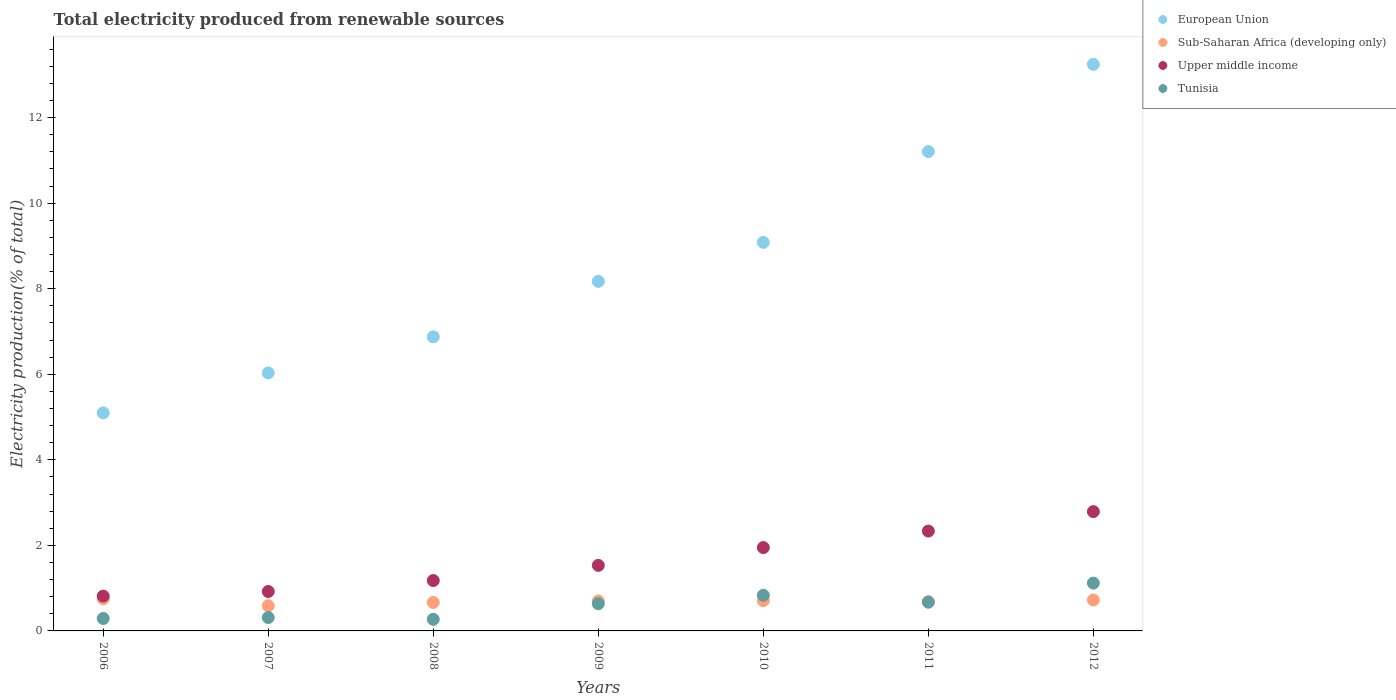How many different coloured dotlines are there?
Provide a succinct answer. 4. Is the number of dotlines equal to the number of legend labels?
Offer a very short reply. Yes. What is the total electricity produced in Tunisia in 2011?
Provide a short and direct response. 0.67. Across all years, what is the maximum total electricity produced in Tunisia?
Offer a terse response. 1.12. Across all years, what is the minimum total electricity produced in Sub-Saharan Africa (developing only)?
Offer a very short reply. 0.59. In which year was the total electricity produced in Upper middle income maximum?
Offer a terse response. 2012. What is the total total electricity produced in Upper middle income in the graph?
Ensure brevity in your answer.  11.52. What is the difference between the total electricity produced in Sub-Saharan Africa (developing only) in 2007 and that in 2008?
Offer a terse response. -0.08. What is the difference between the total electricity produced in Tunisia in 2008 and the total electricity produced in Upper middle income in 2010?
Provide a succinct answer. -1.68. What is the average total electricity produced in Sub-Saharan Africa (developing only) per year?
Offer a very short reply. 0.69. In the year 2008, what is the difference between the total electricity produced in Tunisia and total electricity produced in Sub-Saharan Africa (developing only)?
Provide a short and direct response. -0.39. What is the ratio of the total electricity produced in European Union in 2008 to that in 2010?
Ensure brevity in your answer.  0.76. Is the total electricity produced in Sub-Saharan Africa (developing only) in 2006 less than that in 2010?
Give a very brief answer. No. Is the difference between the total electricity produced in Tunisia in 2008 and 2009 greater than the difference between the total electricity produced in Sub-Saharan Africa (developing only) in 2008 and 2009?
Your answer should be compact. No. What is the difference between the highest and the second highest total electricity produced in Upper middle income?
Keep it short and to the point. 0.45. What is the difference between the highest and the lowest total electricity produced in Tunisia?
Offer a very short reply. 0.85. Is it the case that in every year, the sum of the total electricity produced in European Union and total electricity produced in Tunisia  is greater than the total electricity produced in Upper middle income?
Your answer should be very brief. Yes. Is the total electricity produced in Tunisia strictly less than the total electricity produced in Upper middle income over the years?
Keep it short and to the point. Yes. How many years are there in the graph?
Your answer should be compact. 7. What is the difference between two consecutive major ticks on the Y-axis?
Offer a terse response. 2. Does the graph contain any zero values?
Offer a terse response. No. Does the graph contain grids?
Give a very brief answer. No. What is the title of the graph?
Keep it short and to the point. Total electricity produced from renewable sources. Does "East Asia (all income levels)" appear as one of the legend labels in the graph?
Give a very brief answer. No. What is the Electricity production(% of total) in European Union in 2006?
Provide a short and direct response. 5.1. What is the Electricity production(% of total) in Sub-Saharan Africa (developing only) in 2006?
Provide a short and direct response. 0.75. What is the Electricity production(% of total) of Upper middle income in 2006?
Provide a short and direct response. 0.81. What is the Electricity production(% of total) of Tunisia in 2006?
Your response must be concise. 0.29. What is the Electricity production(% of total) in European Union in 2007?
Offer a terse response. 6.03. What is the Electricity production(% of total) in Sub-Saharan Africa (developing only) in 2007?
Give a very brief answer. 0.59. What is the Electricity production(% of total) in Upper middle income in 2007?
Give a very brief answer. 0.92. What is the Electricity production(% of total) of Tunisia in 2007?
Give a very brief answer. 0.31. What is the Electricity production(% of total) in European Union in 2008?
Make the answer very short. 6.87. What is the Electricity production(% of total) of Sub-Saharan Africa (developing only) in 2008?
Your answer should be compact. 0.67. What is the Electricity production(% of total) in Upper middle income in 2008?
Give a very brief answer. 1.18. What is the Electricity production(% of total) of Tunisia in 2008?
Ensure brevity in your answer.  0.27. What is the Electricity production(% of total) in European Union in 2009?
Your answer should be compact. 8.17. What is the Electricity production(% of total) of Sub-Saharan Africa (developing only) in 2009?
Your answer should be compact. 0.7. What is the Electricity production(% of total) in Upper middle income in 2009?
Your answer should be very brief. 1.53. What is the Electricity production(% of total) in Tunisia in 2009?
Your response must be concise. 0.64. What is the Electricity production(% of total) of European Union in 2010?
Your answer should be compact. 9.08. What is the Electricity production(% of total) of Sub-Saharan Africa (developing only) in 2010?
Your response must be concise. 0.71. What is the Electricity production(% of total) of Upper middle income in 2010?
Keep it short and to the point. 1.95. What is the Electricity production(% of total) in Tunisia in 2010?
Ensure brevity in your answer.  0.83. What is the Electricity production(% of total) of European Union in 2011?
Provide a succinct answer. 11.21. What is the Electricity production(% of total) in Sub-Saharan Africa (developing only) in 2011?
Provide a succinct answer. 0.69. What is the Electricity production(% of total) of Upper middle income in 2011?
Offer a very short reply. 2.33. What is the Electricity production(% of total) in Tunisia in 2011?
Offer a terse response. 0.67. What is the Electricity production(% of total) of European Union in 2012?
Your answer should be compact. 13.25. What is the Electricity production(% of total) of Sub-Saharan Africa (developing only) in 2012?
Keep it short and to the point. 0.72. What is the Electricity production(% of total) of Upper middle income in 2012?
Make the answer very short. 2.79. What is the Electricity production(% of total) of Tunisia in 2012?
Make the answer very short. 1.12. Across all years, what is the maximum Electricity production(% of total) of European Union?
Make the answer very short. 13.25. Across all years, what is the maximum Electricity production(% of total) of Sub-Saharan Africa (developing only)?
Your answer should be compact. 0.75. Across all years, what is the maximum Electricity production(% of total) in Upper middle income?
Keep it short and to the point. 2.79. Across all years, what is the maximum Electricity production(% of total) of Tunisia?
Your answer should be very brief. 1.12. Across all years, what is the minimum Electricity production(% of total) of European Union?
Offer a terse response. 5.1. Across all years, what is the minimum Electricity production(% of total) of Sub-Saharan Africa (developing only)?
Provide a short and direct response. 0.59. Across all years, what is the minimum Electricity production(% of total) in Upper middle income?
Offer a very short reply. 0.81. Across all years, what is the minimum Electricity production(% of total) of Tunisia?
Provide a succinct answer. 0.27. What is the total Electricity production(% of total) of European Union in the graph?
Offer a terse response. 59.71. What is the total Electricity production(% of total) in Sub-Saharan Africa (developing only) in the graph?
Offer a very short reply. 4.82. What is the total Electricity production(% of total) of Upper middle income in the graph?
Give a very brief answer. 11.52. What is the total Electricity production(% of total) in Tunisia in the graph?
Offer a terse response. 4.13. What is the difference between the Electricity production(% of total) in European Union in 2006 and that in 2007?
Make the answer very short. -0.94. What is the difference between the Electricity production(% of total) in Sub-Saharan Africa (developing only) in 2006 and that in 2007?
Make the answer very short. 0.16. What is the difference between the Electricity production(% of total) in Upper middle income in 2006 and that in 2007?
Offer a very short reply. -0.11. What is the difference between the Electricity production(% of total) in Tunisia in 2006 and that in 2007?
Your answer should be very brief. -0.02. What is the difference between the Electricity production(% of total) in European Union in 2006 and that in 2008?
Ensure brevity in your answer.  -1.78. What is the difference between the Electricity production(% of total) of Sub-Saharan Africa (developing only) in 2006 and that in 2008?
Your response must be concise. 0.09. What is the difference between the Electricity production(% of total) of Upper middle income in 2006 and that in 2008?
Make the answer very short. -0.36. What is the difference between the Electricity production(% of total) of Tunisia in 2006 and that in 2008?
Provide a short and direct response. 0.02. What is the difference between the Electricity production(% of total) of European Union in 2006 and that in 2009?
Give a very brief answer. -3.07. What is the difference between the Electricity production(% of total) of Sub-Saharan Africa (developing only) in 2006 and that in 2009?
Provide a short and direct response. 0.05. What is the difference between the Electricity production(% of total) of Upper middle income in 2006 and that in 2009?
Offer a very short reply. -0.72. What is the difference between the Electricity production(% of total) of Tunisia in 2006 and that in 2009?
Give a very brief answer. -0.34. What is the difference between the Electricity production(% of total) in European Union in 2006 and that in 2010?
Offer a very short reply. -3.99. What is the difference between the Electricity production(% of total) in Sub-Saharan Africa (developing only) in 2006 and that in 2010?
Make the answer very short. 0.04. What is the difference between the Electricity production(% of total) in Upper middle income in 2006 and that in 2010?
Your answer should be very brief. -1.13. What is the difference between the Electricity production(% of total) in Tunisia in 2006 and that in 2010?
Your response must be concise. -0.54. What is the difference between the Electricity production(% of total) in European Union in 2006 and that in 2011?
Keep it short and to the point. -6.11. What is the difference between the Electricity production(% of total) of Sub-Saharan Africa (developing only) in 2006 and that in 2011?
Provide a succinct answer. 0.07. What is the difference between the Electricity production(% of total) in Upper middle income in 2006 and that in 2011?
Offer a very short reply. -1.52. What is the difference between the Electricity production(% of total) of Tunisia in 2006 and that in 2011?
Keep it short and to the point. -0.38. What is the difference between the Electricity production(% of total) in European Union in 2006 and that in 2012?
Give a very brief answer. -8.15. What is the difference between the Electricity production(% of total) in Sub-Saharan Africa (developing only) in 2006 and that in 2012?
Keep it short and to the point. 0.03. What is the difference between the Electricity production(% of total) in Upper middle income in 2006 and that in 2012?
Your response must be concise. -1.97. What is the difference between the Electricity production(% of total) in Tunisia in 2006 and that in 2012?
Offer a very short reply. -0.83. What is the difference between the Electricity production(% of total) in European Union in 2007 and that in 2008?
Keep it short and to the point. -0.84. What is the difference between the Electricity production(% of total) of Sub-Saharan Africa (developing only) in 2007 and that in 2008?
Your answer should be compact. -0.08. What is the difference between the Electricity production(% of total) of Upper middle income in 2007 and that in 2008?
Offer a very short reply. -0.26. What is the difference between the Electricity production(% of total) of Tunisia in 2007 and that in 2008?
Your response must be concise. 0.04. What is the difference between the Electricity production(% of total) in European Union in 2007 and that in 2009?
Give a very brief answer. -2.14. What is the difference between the Electricity production(% of total) of Sub-Saharan Africa (developing only) in 2007 and that in 2009?
Ensure brevity in your answer.  -0.11. What is the difference between the Electricity production(% of total) of Upper middle income in 2007 and that in 2009?
Provide a short and direct response. -0.61. What is the difference between the Electricity production(% of total) in Tunisia in 2007 and that in 2009?
Your response must be concise. -0.32. What is the difference between the Electricity production(% of total) of European Union in 2007 and that in 2010?
Provide a short and direct response. -3.05. What is the difference between the Electricity production(% of total) in Sub-Saharan Africa (developing only) in 2007 and that in 2010?
Your answer should be very brief. -0.12. What is the difference between the Electricity production(% of total) of Upper middle income in 2007 and that in 2010?
Ensure brevity in your answer.  -1.03. What is the difference between the Electricity production(% of total) of Tunisia in 2007 and that in 2010?
Your answer should be compact. -0.52. What is the difference between the Electricity production(% of total) in European Union in 2007 and that in 2011?
Your response must be concise. -5.17. What is the difference between the Electricity production(% of total) of Sub-Saharan Africa (developing only) in 2007 and that in 2011?
Provide a short and direct response. -0.1. What is the difference between the Electricity production(% of total) of Upper middle income in 2007 and that in 2011?
Your answer should be very brief. -1.41. What is the difference between the Electricity production(% of total) of Tunisia in 2007 and that in 2011?
Offer a very short reply. -0.36. What is the difference between the Electricity production(% of total) of European Union in 2007 and that in 2012?
Your response must be concise. -7.21. What is the difference between the Electricity production(% of total) of Sub-Saharan Africa (developing only) in 2007 and that in 2012?
Make the answer very short. -0.13. What is the difference between the Electricity production(% of total) in Upper middle income in 2007 and that in 2012?
Provide a short and direct response. -1.87. What is the difference between the Electricity production(% of total) in Tunisia in 2007 and that in 2012?
Offer a terse response. -0.8. What is the difference between the Electricity production(% of total) of European Union in 2008 and that in 2009?
Provide a succinct answer. -1.3. What is the difference between the Electricity production(% of total) of Sub-Saharan Africa (developing only) in 2008 and that in 2009?
Make the answer very short. -0.03. What is the difference between the Electricity production(% of total) of Upper middle income in 2008 and that in 2009?
Give a very brief answer. -0.35. What is the difference between the Electricity production(% of total) of Tunisia in 2008 and that in 2009?
Give a very brief answer. -0.36. What is the difference between the Electricity production(% of total) in European Union in 2008 and that in 2010?
Provide a succinct answer. -2.21. What is the difference between the Electricity production(% of total) of Sub-Saharan Africa (developing only) in 2008 and that in 2010?
Make the answer very short. -0.04. What is the difference between the Electricity production(% of total) of Upper middle income in 2008 and that in 2010?
Give a very brief answer. -0.77. What is the difference between the Electricity production(% of total) of Tunisia in 2008 and that in 2010?
Give a very brief answer. -0.56. What is the difference between the Electricity production(% of total) of European Union in 2008 and that in 2011?
Offer a terse response. -4.33. What is the difference between the Electricity production(% of total) of Sub-Saharan Africa (developing only) in 2008 and that in 2011?
Offer a terse response. -0.02. What is the difference between the Electricity production(% of total) in Upper middle income in 2008 and that in 2011?
Keep it short and to the point. -1.16. What is the difference between the Electricity production(% of total) in Tunisia in 2008 and that in 2011?
Offer a very short reply. -0.4. What is the difference between the Electricity production(% of total) of European Union in 2008 and that in 2012?
Make the answer very short. -6.37. What is the difference between the Electricity production(% of total) of Sub-Saharan Africa (developing only) in 2008 and that in 2012?
Provide a short and direct response. -0.06. What is the difference between the Electricity production(% of total) of Upper middle income in 2008 and that in 2012?
Your answer should be compact. -1.61. What is the difference between the Electricity production(% of total) in Tunisia in 2008 and that in 2012?
Give a very brief answer. -0.85. What is the difference between the Electricity production(% of total) in European Union in 2009 and that in 2010?
Give a very brief answer. -0.91. What is the difference between the Electricity production(% of total) of Sub-Saharan Africa (developing only) in 2009 and that in 2010?
Offer a terse response. -0.01. What is the difference between the Electricity production(% of total) of Upper middle income in 2009 and that in 2010?
Keep it short and to the point. -0.42. What is the difference between the Electricity production(% of total) of Tunisia in 2009 and that in 2010?
Your answer should be very brief. -0.2. What is the difference between the Electricity production(% of total) in European Union in 2009 and that in 2011?
Offer a very short reply. -3.04. What is the difference between the Electricity production(% of total) of Sub-Saharan Africa (developing only) in 2009 and that in 2011?
Your answer should be compact. 0.01. What is the difference between the Electricity production(% of total) of Upper middle income in 2009 and that in 2011?
Provide a short and direct response. -0.8. What is the difference between the Electricity production(% of total) of Tunisia in 2009 and that in 2011?
Make the answer very short. -0.04. What is the difference between the Electricity production(% of total) in European Union in 2009 and that in 2012?
Offer a very short reply. -5.07. What is the difference between the Electricity production(% of total) of Sub-Saharan Africa (developing only) in 2009 and that in 2012?
Offer a very short reply. -0.02. What is the difference between the Electricity production(% of total) in Upper middle income in 2009 and that in 2012?
Your answer should be very brief. -1.26. What is the difference between the Electricity production(% of total) in Tunisia in 2009 and that in 2012?
Your response must be concise. -0.48. What is the difference between the Electricity production(% of total) in European Union in 2010 and that in 2011?
Your answer should be very brief. -2.12. What is the difference between the Electricity production(% of total) in Sub-Saharan Africa (developing only) in 2010 and that in 2011?
Make the answer very short. 0.02. What is the difference between the Electricity production(% of total) in Upper middle income in 2010 and that in 2011?
Make the answer very short. -0.39. What is the difference between the Electricity production(% of total) of Tunisia in 2010 and that in 2011?
Offer a terse response. 0.16. What is the difference between the Electricity production(% of total) of European Union in 2010 and that in 2012?
Make the answer very short. -4.16. What is the difference between the Electricity production(% of total) in Sub-Saharan Africa (developing only) in 2010 and that in 2012?
Offer a very short reply. -0.02. What is the difference between the Electricity production(% of total) in Upper middle income in 2010 and that in 2012?
Your answer should be compact. -0.84. What is the difference between the Electricity production(% of total) of Tunisia in 2010 and that in 2012?
Make the answer very short. -0.28. What is the difference between the Electricity production(% of total) of European Union in 2011 and that in 2012?
Provide a succinct answer. -2.04. What is the difference between the Electricity production(% of total) of Sub-Saharan Africa (developing only) in 2011 and that in 2012?
Provide a short and direct response. -0.04. What is the difference between the Electricity production(% of total) of Upper middle income in 2011 and that in 2012?
Keep it short and to the point. -0.45. What is the difference between the Electricity production(% of total) in Tunisia in 2011 and that in 2012?
Make the answer very short. -0.45. What is the difference between the Electricity production(% of total) of European Union in 2006 and the Electricity production(% of total) of Sub-Saharan Africa (developing only) in 2007?
Offer a very short reply. 4.51. What is the difference between the Electricity production(% of total) of European Union in 2006 and the Electricity production(% of total) of Upper middle income in 2007?
Offer a terse response. 4.17. What is the difference between the Electricity production(% of total) in European Union in 2006 and the Electricity production(% of total) in Tunisia in 2007?
Your answer should be very brief. 4.78. What is the difference between the Electricity production(% of total) in Sub-Saharan Africa (developing only) in 2006 and the Electricity production(% of total) in Upper middle income in 2007?
Ensure brevity in your answer.  -0.17. What is the difference between the Electricity production(% of total) in Sub-Saharan Africa (developing only) in 2006 and the Electricity production(% of total) in Tunisia in 2007?
Offer a very short reply. 0.44. What is the difference between the Electricity production(% of total) in Upper middle income in 2006 and the Electricity production(% of total) in Tunisia in 2007?
Offer a terse response. 0.5. What is the difference between the Electricity production(% of total) of European Union in 2006 and the Electricity production(% of total) of Sub-Saharan Africa (developing only) in 2008?
Provide a succinct answer. 4.43. What is the difference between the Electricity production(% of total) of European Union in 2006 and the Electricity production(% of total) of Upper middle income in 2008?
Your answer should be compact. 3.92. What is the difference between the Electricity production(% of total) in European Union in 2006 and the Electricity production(% of total) in Tunisia in 2008?
Ensure brevity in your answer.  4.82. What is the difference between the Electricity production(% of total) in Sub-Saharan Africa (developing only) in 2006 and the Electricity production(% of total) in Upper middle income in 2008?
Make the answer very short. -0.43. What is the difference between the Electricity production(% of total) of Sub-Saharan Africa (developing only) in 2006 and the Electricity production(% of total) of Tunisia in 2008?
Offer a very short reply. 0.48. What is the difference between the Electricity production(% of total) in Upper middle income in 2006 and the Electricity production(% of total) in Tunisia in 2008?
Your answer should be very brief. 0.54. What is the difference between the Electricity production(% of total) in European Union in 2006 and the Electricity production(% of total) in Sub-Saharan Africa (developing only) in 2009?
Your answer should be compact. 4.4. What is the difference between the Electricity production(% of total) in European Union in 2006 and the Electricity production(% of total) in Upper middle income in 2009?
Provide a short and direct response. 3.56. What is the difference between the Electricity production(% of total) of European Union in 2006 and the Electricity production(% of total) of Tunisia in 2009?
Offer a very short reply. 4.46. What is the difference between the Electricity production(% of total) in Sub-Saharan Africa (developing only) in 2006 and the Electricity production(% of total) in Upper middle income in 2009?
Give a very brief answer. -0.78. What is the difference between the Electricity production(% of total) of Sub-Saharan Africa (developing only) in 2006 and the Electricity production(% of total) of Tunisia in 2009?
Ensure brevity in your answer.  0.12. What is the difference between the Electricity production(% of total) in Upper middle income in 2006 and the Electricity production(% of total) in Tunisia in 2009?
Provide a short and direct response. 0.18. What is the difference between the Electricity production(% of total) of European Union in 2006 and the Electricity production(% of total) of Sub-Saharan Africa (developing only) in 2010?
Your answer should be very brief. 4.39. What is the difference between the Electricity production(% of total) in European Union in 2006 and the Electricity production(% of total) in Upper middle income in 2010?
Offer a very short reply. 3.15. What is the difference between the Electricity production(% of total) of European Union in 2006 and the Electricity production(% of total) of Tunisia in 2010?
Your answer should be very brief. 4.26. What is the difference between the Electricity production(% of total) in Sub-Saharan Africa (developing only) in 2006 and the Electricity production(% of total) in Upper middle income in 2010?
Ensure brevity in your answer.  -1.2. What is the difference between the Electricity production(% of total) in Sub-Saharan Africa (developing only) in 2006 and the Electricity production(% of total) in Tunisia in 2010?
Offer a terse response. -0.08. What is the difference between the Electricity production(% of total) of Upper middle income in 2006 and the Electricity production(% of total) of Tunisia in 2010?
Keep it short and to the point. -0.02. What is the difference between the Electricity production(% of total) in European Union in 2006 and the Electricity production(% of total) in Sub-Saharan Africa (developing only) in 2011?
Your answer should be very brief. 4.41. What is the difference between the Electricity production(% of total) in European Union in 2006 and the Electricity production(% of total) in Upper middle income in 2011?
Offer a terse response. 2.76. What is the difference between the Electricity production(% of total) of European Union in 2006 and the Electricity production(% of total) of Tunisia in 2011?
Your answer should be compact. 4.43. What is the difference between the Electricity production(% of total) of Sub-Saharan Africa (developing only) in 2006 and the Electricity production(% of total) of Upper middle income in 2011?
Your answer should be very brief. -1.58. What is the difference between the Electricity production(% of total) of Sub-Saharan Africa (developing only) in 2006 and the Electricity production(% of total) of Tunisia in 2011?
Keep it short and to the point. 0.08. What is the difference between the Electricity production(% of total) of Upper middle income in 2006 and the Electricity production(% of total) of Tunisia in 2011?
Provide a succinct answer. 0.14. What is the difference between the Electricity production(% of total) of European Union in 2006 and the Electricity production(% of total) of Sub-Saharan Africa (developing only) in 2012?
Provide a short and direct response. 4.37. What is the difference between the Electricity production(% of total) of European Union in 2006 and the Electricity production(% of total) of Upper middle income in 2012?
Offer a very short reply. 2.31. What is the difference between the Electricity production(% of total) of European Union in 2006 and the Electricity production(% of total) of Tunisia in 2012?
Ensure brevity in your answer.  3.98. What is the difference between the Electricity production(% of total) of Sub-Saharan Africa (developing only) in 2006 and the Electricity production(% of total) of Upper middle income in 2012?
Offer a terse response. -2.04. What is the difference between the Electricity production(% of total) of Sub-Saharan Africa (developing only) in 2006 and the Electricity production(% of total) of Tunisia in 2012?
Ensure brevity in your answer.  -0.37. What is the difference between the Electricity production(% of total) of Upper middle income in 2006 and the Electricity production(% of total) of Tunisia in 2012?
Provide a succinct answer. -0.3. What is the difference between the Electricity production(% of total) of European Union in 2007 and the Electricity production(% of total) of Sub-Saharan Africa (developing only) in 2008?
Your response must be concise. 5.37. What is the difference between the Electricity production(% of total) in European Union in 2007 and the Electricity production(% of total) in Upper middle income in 2008?
Provide a short and direct response. 4.85. What is the difference between the Electricity production(% of total) of European Union in 2007 and the Electricity production(% of total) of Tunisia in 2008?
Make the answer very short. 5.76. What is the difference between the Electricity production(% of total) in Sub-Saharan Africa (developing only) in 2007 and the Electricity production(% of total) in Upper middle income in 2008?
Your response must be concise. -0.59. What is the difference between the Electricity production(% of total) in Sub-Saharan Africa (developing only) in 2007 and the Electricity production(% of total) in Tunisia in 2008?
Provide a succinct answer. 0.32. What is the difference between the Electricity production(% of total) of Upper middle income in 2007 and the Electricity production(% of total) of Tunisia in 2008?
Your answer should be compact. 0.65. What is the difference between the Electricity production(% of total) of European Union in 2007 and the Electricity production(% of total) of Sub-Saharan Africa (developing only) in 2009?
Make the answer very short. 5.33. What is the difference between the Electricity production(% of total) of European Union in 2007 and the Electricity production(% of total) of Upper middle income in 2009?
Keep it short and to the point. 4.5. What is the difference between the Electricity production(% of total) in European Union in 2007 and the Electricity production(% of total) in Tunisia in 2009?
Your response must be concise. 5.4. What is the difference between the Electricity production(% of total) of Sub-Saharan Africa (developing only) in 2007 and the Electricity production(% of total) of Upper middle income in 2009?
Your answer should be very brief. -0.94. What is the difference between the Electricity production(% of total) of Sub-Saharan Africa (developing only) in 2007 and the Electricity production(% of total) of Tunisia in 2009?
Offer a terse response. -0.05. What is the difference between the Electricity production(% of total) in Upper middle income in 2007 and the Electricity production(% of total) in Tunisia in 2009?
Offer a terse response. 0.29. What is the difference between the Electricity production(% of total) of European Union in 2007 and the Electricity production(% of total) of Sub-Saharan Africa (developing only) in 2010?
Give a very brief answer. 5.32. What is the difference between the Electricity production(% of total) in European Union in 2007 and the Electricity production(% of total) in Upper middle income in 2010?
Provide a succinct answer. 4.08. What is the difference between the Electricity production(% of total) in European Union in 2007 and the Electricity production(% of total) in Tunisia in 2010?
Provide a succinct answer. 5.2. What is the difference between the Electricity production(% of total) of Sub-Saharan Africa (developing only) in 2007 and the Electricity production(% of total) of Upper middle income in 2010?
Your response must be concise. -1.36. What is the difference between the Electricity production(% of total) in Sub-Saharan Africa (developing only) in 2007 and the Electricity production(% of total) in Tunisia in 2010?
Provide a succinct answer. -0.24. What is the difference between the Electricity production(% of total) of Upper middle income in 2007 and the Electricity production(% of total) of Tunisia in 2010?
Provide a succinct answer. 0.09. What is the difference between the Electricity production(% of total) of European Union in 2007 and the Electricity production(% of total) of Sub-Saharan Africa (developing only) in 2011?
Give a very brief answer. 5.35. What is the difference between the Electricity production(% of total) of European Union in 2007 and the Electricity production(% of total) of Upper middle income in 2011?
Provide a succinct answer. 3.7. What is the difference between the Electricity production(% of total) of European Union in 2007 and the Electricity production(% of total) of Tunisia in 2011?
Keep it short and to the point. 5.36. What is the difference between the Electricity production(% of total) of Sub-Saharan Africa (developing only) in 2007 and the Electricity production(% of total) of Upper middle income in 2011?
Your answer should be very brief. -1.75. What is the difference between the Electricity production(% of total) of Sub-Saharan Africa (developing only) in 2007 and the Electricity production(% of total) of Tunisia in 2011?
Your answer should be very brief. -0.08. What is the difference between the Electricity production(% of total) of Upper middle income in 2007 and the Electricity production(% of total) of Tunisia in 2011?
Provide a succinct answer. 0.25. What is the difference between the Electricity production(% of total) in European Union in 2007 and the Electricity production(% of total) in Sub-Saharan Africa (developing only) in 2012?
Offer a very short reply. 5.31. What is the difference between the Electricity production(% of total) in European Union in 2007 and the Electricity production(% of total) in Upper middle income in 2012?
Provide a short and direct response. 3.24. What is the difference between the Electricity production(% of total) of European Union in 2007 and the Electricity production(% of total) of Tunisia in 2012?
Provide a succinct answer. 4.91. What is the difference between the Electricity production(% of total) in Sub-Saharan Africa (developing only) in 2007 and the Electricity production(% of total) in Upper middle income in 2012?
Provide a short and direct response. -2.2. What is the difference between the Electricity production(% of total) in Sub-Saharan Africa (developing only) in 2007 and the Electricity production(% of total) in Tunisia in 2012?
Give a very brief answer. -0.53. What is the difference between the Electricity production(% of total) of Upper middle income in 2007 and the Electricity production(% of total) of Tunisia in 2012?
Offer a terse response. -0.2. What is the difference between the Electricity production(% of total) in European Union in 2008 and the Electricity production(% of total) in Sub-Saharan Africa (developing only) in 2009?
Provide a short and direct response. 6.18. What is the difference between the Electricity production(% of total) in European Union in 2008 and the Electricity production(% of total) in Upper middle income in 2009?
Give a very brief answer. 5.34. What is the difference between the Electricity production(% of total) in European Union in 2008 and the Electricity production(% of total) in Tunisia in 2009?
Make the answer very short. 6.24. What is the difference between the Electricity production(% of total) of Sub-Saharan Africa (developing only) in 2008 and the Electricity production(% of total) of Upper middle income in 2009?
Your response must be concise. -0.87. What is the difference between the Electricity production(% of total) of Sub-Saharan Africa (developing only) in 2008 and the Electricity production(% of total) of Tunisia in 2009?
Offer a very short reply. 0.03. What is the difference between the Electricity production(% of total) in Upper middle income in 2008 and the Electricity production(% of total) in Tunisia in 2009?
Keep it short and to the point. 0.54. What is the difference between the Electricity production(% of total) of European Union in 2008 and the Electricity production(% of total) of Sub-Saharan Africa (developing only) in 2010?
Your answer should be very brief. 6.17. What is the difference between the Electricity production(% of total) of European Union in 2008 and the Electricity production(% of total) of Upper middle income in 2010?
Provide a succinct answer. 4.93. What is the difference between the Electricity production(% of total) of European Union in 2008 and the Electricity production(% of total) of Tunisia in 2010?
Keep it short and to the point. 6.04. What is the difference between the Electricity production(% of total) of Sub-Saharan Africa (developing only) in 2008 and the Electricity production(% of total) of Upper middle income in 2010?
Your answer should be compact. -1.28. What is the difference between the Electricity production(% of total) of Sub-Saharan Africa (developing only) in 2008 and the Electricity production(% of total) of Tunisia in 2010?
Keep it short and to the point. -0.17. What is the difference between the Electricity production(% of total) in Upper middle income in 2008 and the Electricity production(% of total) in Tunisia in 2010?
Your answer should be compact. 0.35. What is the difference between the Electricity production(% of total) of European Union in 2008 and the Electricity production(% of total) of Sub-Saharan Africa (developing only) in 2011?
Make the answer very short. 6.19. What is the difference between the Electricity production(% of total) in European Union in 2008 and the Electricity production(% of total) in Upper middle income in 2011?
Give a very brief answer. 4.54. What is the difference between the Electricity production(% of total) of European Union in 2008 and the Electricity production(% of total) of Tunisia in 2011?
Your response must be concise. 6.2. What is the difference between the Electricity production(% of total) in Sub-Saharan Africa (developing only) in 2008 and the Electricity production(% of total) in Upper middle income in 2011?
Your response must be concise. -1.67. What is the difference between the Electricity production(% of total) in Sub-Saharan Africa (developing only) in 2008 and the Electricity production(% of total) in Tunisia in 2011?
Provide a succinct answer. -0.01. What is the difference between the Electricity production(% of total) of Upper middle income in 2008 and the Electricity production(% of total) of Tunisia in 2011?
Offer a very short reply. 0.51. What is the difference between the Electricity production(% of total) of European Union in 2008 and the Electricity production(% of total) of Sub-Saharan Africa (developing only) in 2012?
Provide a short and direct response. 6.15. What is the difference between the Electricity production(% of total) in European Union in 2008 and the Electricity production(% of total) in Upper middle income in 2012?
Your response must be concise. 4.09. What is the difference between the Electricity production(% of total) of European Union in 2008 and the Electricity production(% of total) of Tunisia in 2012?
Provide a short and direct response. 5.76. What is the difference between the Electricity production(% of total) of Sub-Saharan Africa (developing only) in 2008 and the Electricity production(% of total) of Upper middle income in 2012?
Your answer should be compact. -2.12. What is the difference between the Electricity production(% of total) of Sub-Saharan Africa (developing only) in 2008 and the Electricity production(% of total) of Tunisia in 2012?
Provide a succinct answer. -0.45. What is the difference between the Electricity production(% of total) of Upper middle income in 2008 and the Electricity production(% of total) of Tunisia in 2012?
Offer a terse response. 0.06. What is the difference between the Electricity production(% of total) in European Union in 2009 and the Electricity production(% of total) in Sub-Saharan Africa (developing only) in 2010?
Your answer should be very brief. 7.46. What is the difference between the Electricity production(% of total) of European Union in 2009 and the Electricity production(% of total) of Upper middle income in 2010?
Give a very brief answer. 6.22. What is the difference between the Electricity production(% of total) in European Union in 2009 and the Electricity production(% of total) in Tunisia in 2010?
Provide a succinct answer. 7.34. What is the difference between the Electricity production(% of total) of Sub-Saharan Africa (developing only) in 2009 and the Electricity production(% of total) of Upper middle income in 2010?
Your answer should be very brief. -1.25. What is the difference between the Electricity production(% of total) in Sub-Saharan Africa (developing only) in 2009 and the Electricity production(% of total) in Tunisia in 2010?
Offer a very short reply. -0.13. What is the difference between the Electricity production(% of total) of Upper middle income in 2009 and the Electricity production(% of total) of Tunisia in 2010?
Offer a very short reply. 0.7. What is the difference between the Electricity production(% of total) in European Union in 2009 and the Electricity production(% of total) in Sub-Saharan Africa (developing only) in 2011?
Ensure brevity in your answer.  7.48. What is the difference between the Electricity production(% of total) in European Union in 2009 and the Electricity production(% of total) in Upper middle income in 2011?
Keep it short and to the point. 5.84. What is the difference between the Electricity production(% of total) of European Union in 2009 and the Electricity production(% of total) of Tunisia in 2011?
Make the answer very short. 7.5. What is the difference between the Electricity production(% of total) in Sub-Saharan Africa (developing only) in 2009 and the Electricity production(% of total) in Upper middle income in 2011?
Provide a short and direct response. -1.64. What is the difference between the Electricity production(% of total) in Sub-Saharan Africa (developing only) in 2009 and the Electricity production(% of total) in Tunisia in 2011?
Offer a terse response. 0.03. What is the difference between the Electricity production(% of total) of Upper middle income in 2009 and the Electricity production(% of total) of Tunisia in 2011?
Your answer should be compact. 0.86. What is the difference between the Electricity production(% of total) in European Union in 2009 and the Electricity production(% of total) in Sub-Saharan Africa (developing only) in 2012?
Ensure brevity in your answer.  7.45. What is the difference between the Electricity production(% of total) of European Union in 2009 and the Electricity production(% of total) of Upper middle income in 2012?
Give a very brief answer. 5.38. What is the difference between the Electricity production(% of total) in European Union in 2009 and the Electricity production(% of total) in Tunisia in 2012?
Keep it short and to the point. 7.05. What is the difference between the Electricity production(% of total) in Sub-Saharan Africa (developing only) in 2009 and the Electricity production(% of total) in Upper middle income in 2012?
Offer a very short reply. -2.09. What is the difference between the Electricity production(% of total) of Sub-Saharan Africa (developing only) in 2009 and the Electricity production(% of total) of Tunisia in 2012?
Offer a terse response. -0.42. What is the difference between the Electricity production(% of total) of Upper middle income in 2009 and the Electricity production(% of total) of Tunisia in 2012?
Offer a terse response. 0.41. What is the difference between the Electricity production(% of total) in European Union in 2010 and the Electricity production(% of total) in Sub-Saharan Africa (developing only) in 2011?
Your answer should be compact. 8.4. What is the difference between the Electricity production(% of total) of European Union in 2010 and the Electricity production(% of total) of Upper middle income in 2011?
Your answer should be compact. 6.75. What is the difference between the Electricity production(% of total) in European Union in 2010 and the Electricity production(% of total) in Tunisia in 2011?
Make the answer very short. 8.41. What is the difference between the Electricity production(% of total) of Sub-Saharan Africa (developing only) in 2010 and the Electricity production(% of total) of Upper middle income in 2011?
Make the answer very short. -1.63. What is the difference between the Electricity production(% of total) in Sub-Saharan Africa (developing only) in 2010 and the Electricity production(% of total) in Tunisia in 2011?
Ensure brevity in your answer.  0.04. What is the difference between the Electricity production(% of total) in Upper middle income in 2010 and the Electricity production(% of total) in Tunisia in 2011?
Make the answer very short. 1.28. What is the difference between the Electricity production(% of total) in European Union in 2010 and the Electricity production(% of total) in Sub-Saharan Africa (developing only) in 2012?
Provide a short and direct response. 8.36. What is the difference between the Electricity production(% of total) in European Union in 2010 and the Electricity production(% of total) in Upper middle income in 2012?
Keep it short and to the point. 6.29. What is the difference between the Electricity production(% of total) in European Union in 2010 and the Electricity production(% of total) in Tunisia in 2012?
Give a very brief answer. 7.97. What is the difference between the Electricity production(% of total) of Sub-Saharan Africa (developing only) in 2010 and the Electricity production(% of total) of Upper middle income in 2012?
Offer a very short reply. -2.08. What is the difference between the Electricity production(% of total) in Sub-Saharan Africa (developing only) in 2010 and the Electricity production(% of total) in Tunisia in 2012?
Ensure brevity in your answer.  -0.41. What is the difference between the Electricity production(% of total) of Upper middle income in 2010 and the Electricity production(% of total) of Tunisia in 2012?
Make the answer very short. 0.83. What is the difference between the Electricity production(% of total) of European Union in 2011 and the Electricity production(% of total) of Sub-Saharan Africa (developing only) in 2012?
Give a very brief answer. 10.48. What is the difference between the Electricity production(% of total) in European Union in 2011 and the Electricity production(% of total) in Upper middle income in 2012?
Ensure brevity in your answer.  8.42. What is the difference between the Electricity production(% of total) of European Union in 2011 and the Electricity production(% of total) of Tunisia in 2012?
Keep it short and to the point. 10.09. What is the difference between the Electricity production(% of total) of Sub-Saharan Africa (developing only) in 2011 and the Electricity production(% of total) of Upper middle income in 2012?
Ensure brevity in your answer.  -2.1. What is the difference between the Electricity production(% of total) of Sub-Saharan Africa (developing only) in 2011 and the Electricity production(% of total) of Tunisia in 2012?
Ensure brevity in your answer.  -0.43. What is the difference between the Electricity production(% of total) of Upper middle income in 2011 and the Electricity production(% of total) of Tunisia in 2012?
Your answer should be very brief. 1.22. What is the average Electricity production(% of total) of European Union per year?
Your answer should be very brief. 8.53. What is the average Electricity production(% of total) in Sub-Saharan Africa (developing only) per year?
Your answer should be very brief. 0.69. What is the average Electricity production(% of total) of Upper middle income per year?
Give a very brief answer. 1.65. What is the average Electricity production(% of total) in Tunisia per year?
Offer a terse response. 0.59. In the year 2006, what is the difference between the Electricity production(% of total) in European Union and Electricity production(% of total) in Sub-Saharan Africa (developing only)?
Ensure brevity in your answer.  4.34. In the year 2006, what is the difference between the Electricity production(% of total) of European Union and Electricity production(% of total) of Upper middle income?
Your answer should be compact. 4.28. In the year 2006, what is the difference between the Electricity production(% of total) of European Union and Electricity production(% of total) of Tunisia?
Provide a short and direct response. 4.81. In the year 2006, what is the difference between the Electricity production(% of total) of Sub-Saharan Africa (developing only) and Electricity production(% of total) of Upper middle income?
Ensure brevity in your answer.  -0.06. In the year 2006, what is the difference between the Electricity production(% of total) of Sub-Saharan Africa (developing only) and Electricity production(% of total) of Tunisia?
Provide a short and direct response. 0.46. In the year 2006, what is the difference between the Electricity production(% of total) of Upper middle income and Electricity production(% of total) of Tunisia?
Keep it short and to the point. 0.52. In the year 2007, what is the difference between the Electricity production(% of total) of European Union and Electricity production(% of total) of Sub-Saharan Africa (developing only)?
Provide a succinct answer. 5.44. In the year 2007, what is the difference between the Electricity production(% of total) in European Union and Electricity production(% of total) in Upper middle income?
Provide a succinct answer. 5.11. In the year 2007, what is the difference between the Electricity production(% of total) in European Union and Electricity production(% of total) in Tunisia?
Provide a short and direct response. 5.72. In the year 2007, what is the difference between the Electricity production(% of total) in Sub-Saharan Africa (developing only) and Electricity production(% of total) in Upper middle income?
Your response must be concise. -0.33. In the year 2007, what is the difference between the Electricity production(% of total) in Sub-Saharan Africa (developing only) and Electricity production(% of total) in Tunisia?
Keep it short and to the point. 0.28. In the year 2007, what is the difference between the Electricity production(% of total) in Upper middle income and Electricity production(% of total) in Tunisia?
Your answer should be very brief. 0.61. In the year 2008, what is the difference between the Electricity production(% of total) in European Union and Electricity production(% of total) in Sub-Saharan Africa (developing only)?
Ensure brevity in your answer.  6.21. In the year 2008, what is the difference between the Electricity production(% of total) of European Union and Electricity production(% of total) of Upper middle income?
Your answer should be very brief. 5.7. In the year 2008, what is the difference between the Electricity production(% of total) of European Union and Electricity production(% of total) of Tunisia?
Your answer should be very brief. 6.6. In the year 2008, what is the difference between the Electricity production(% of total) in Sub-Saharan Africa (developing only) and Electricity production(% of total) in Upper middle income?
Give a very brief answer. -0.51. In the year 2008, what is the difference between the Electricity production(% of total) of Sub-Saharan Africa (developing only) and Electricity production(% of total) of Tunisia?
Keep it short and to the point. 0.39. In the year 2008, what is the difference between the Electricity production(% of total) in Upper middle income and Electricity production(% of total) in Tunisia?
Give a very brief answer. 0.91. In the year 2009, what is the difference between the Electricity production(% of total) in European Union and Electricity production(% of total) in Sub-Saharan Africa (developing only)?
Offer a very short reply. 7.47. In the year 2009, what is the difference between the Electricity production(% of total) in European Union and Electricity production(% of total) in Upper middle income?
Offer a terse response. 6.64. In the year 2009, what is the difference between the Electricity production(% of total) in European Union and Electricity production(% of total) in Tunisia?
Keep it short and to the point. 7.54. In the year 2009, what is the difference between the Electricity production(% of total) of Sub-Saharan Africa (developing only) and Electricity production(% of total) of Upper middle income?
Keep it short and to the point. -0.83. In the year 2009, what is the difference between the Electricity production(% of total) in Sub-Saharan Africa (developing only) and Electricity production(% of total) in Tunisia?
Ensure brevity in your answer.  0.06. In the year 2009, what is the difference between the Electricity production(% of total) in Upper middle income and Electricity production(% of total) in Tunisia?
Your answer should be very brief. 0.9. In the year 2010, what is the difference between the Electricity production(% of total) of European Union and Electricity production(% of total) of Sub-Saharan Africa (developing only)?
Provide a succinct answer. 8.38. In the year 2010, what is the difference between the Electricity production(% of total) of European Union and Electricity production(% of total) of Upper middle income?
Offer a terse response. 7.13. In the year 2010, what is the difference between the Electricity production(% of total) of European Union and Electricity production(% of total) of Tunisia?
Keep it short and to the point. 8.25. In the year 2010, what is the difference between the Electricity production(% of total) of Sub-Saharan Africa (developing only) and Electricity production(% of total) of Upper middle income?
Offer a terse response. -1.24. In the year 2010, what is the difference between the Electricity production(% of total) in Sub-Saharan Africa (developing only) and Electricity production(% of total) in Tunisia?
Provide a succinct answer. -0.13. In the year 2010, what is the difference between the Electricity production(% of total) in Upper middle income and Electricity production(% of total) in Tunisia?
Offer a very short reply. 1.12. In the year 2011, what is the difference between the Electricity production(% of total) of European Union and Electricity production(% of total) of Sub-Saharan Africa (developing only)?
Make the answer very short. 10.52. In the year 2011, what is the difference between the Electricity production(% of total) in European Union and Electricity production(% of total) in Upper middle income?
Offer a very short reply. 8.87. In the year 2011, what is the difference between the Electricity production(% of total) of European Union and Electricity production(% of total) of Tunisia?
Provide a short and direct response. 10.54. In the year 2011, what is the difference between the Electricity production(% of total) in Sub-Saharan Africa (developing only) and Electricity production(% of total) in Upper middle income?
Your response must be concise. -1.65. In the year 2011, what is the difference between the Electricity production(% of total) of Sub-Saharan Africa (developing only) and Electricity production(% of total) of Tunisia?
Offer a terse response. 0.02. In the year 2011, what is the difference between the Electricity production(% of total) of Upper middle income and Electricity production(% of total) of Tunisia?
Keep it short and to the point. 1.66. In the year 2012, what is the difference between the Electricity production(% of total) in European Union and Electricity production(% of total) in Sub-Saharan Africa (developing only)?
Make the answer very short. 12.52. In the year 2012, what is the difference between the Electricity production(% of total) in European Union and Electricity production(% of total) in Upper middle income?
Provide a succinct answer. 10.46. In the year 2012, what is the difference between the Electricity production(% of total) in European Union and Electricity production(% of total) in Tunisia?
Your answer should be compact. 12.13. In the year 2012, what is the difference between the Electricity production(% of total) in Sub-Saharan Africa (developing only) and Electricity production(% of total) in Upper middle income?
Your answer should be compact. -2.07. In the year 2012, what is the difference between the Electricity production(% of total) of Sub-Saharan Africa (developing only) and Electricity production(% of total) of Tunisia?
Offer a very short reply. -0.39. In the year 2012, what is the difference between the Electricity production(% of total) of Upper middle income and Electricity production(% of total) of Tunisia?
Offer a terse response. 1.67. What is the ratio of the Electricity production(% of total) of European Union in 2006 to that in 2007?
Make the answer very short. 0.84. What is the ratio of the Electricity production(% of total) in Sub-Saharan Africa (developing only) in 2006 to that in 2007?
Make the answer very short. 1.28. What is the ratio of the Electricity production(% of total) of Upper middle income in 2006 to that in 2007?
Your response must be concise. 0.88. What is the ratio of the Electricity production(% of total) in Tunisia in 2006 to that in 2007?
Make the answer very short. 0.93. What is the ratio of the Electricity production(% of total) in European Union in 2006 to that in 2008?
Keep it short and to the point. 0.74. What is the ratio of the Electricity production(% of total) in Sub-Saharan Africa (developing only) in 2006 to that in 2008?
Your response must be concise. 1.13. What is the ratio of the Electricity production(% of total) of Upper middle income in 2006 to that in 2008?
Offer a terse response. 0.69. What is the ratio of the Electricity production(% of total) in Tunisia in 2006 to that in 2008?
Provide a short and direct response. 1.07. What is the ratio of the Electricity production(% of total) of European Union in 2006 to that in 2009?
Ensure brevity in your answer.  0.62. What is the ratio of the Electricity production(% of total) in Sub-Saharan Africa (developing only) in 2006 to that in 2009?
Your answer should be very brief. 1.08. What is the ratio of the Electricity production(% of total) of Upper middle income in 2006 to that in 2009?
Provide a succinct answer. 0.53. What is the ratio of the Electricity production(% of total) in Tunisia in 2006 to that in 2009?
Offer a very short reply. 0.46. What is the ratio of the Electricity production(% of total) in European Union in 2006 to that in 2010?
Make the answer very short. 0.56. What is the ratio of the Electricity production(% of total) in Sub-Saharan Africa (developing only) in 2006 to that in 2010?
Your answer should be very brief. 1.06. What is the ratio of the Electricity production(% of total) of Upper middle income in 2006 to that in 2010?
Offer a terse response. 0.42. What is the ratio of the Electricity production(% of total) of Tunisia in 2006 to that in 2010?
Provide a short and direct response. 0.35. What is the ratio of the Electricity production(% of total) of European Union in 2006 to that in 2011?
Ensure brevity in your answer.  0.45. What is the ratio of the Electricity production(% of total) of Sub-Saharan Africa (developing only) in 2006 to that in 2011?
Your response must be concise. 1.09. What is the ratio of the Electricity production(% of total) in Upper middle income in 2006 to that in 2011?
Your response must be concise. 0.35. What is the ratio of the Electricity production(% of total) in Tunisia in 2006 to that in 2011?
Offer a very short reply. 0.43. What is the ratio of the Electricity production(% of total) in European Union in 2006 to that in 2012?
Offer a terse response. 0.38. What is the ratio of the Electricity production(% of total) in Upper middle income in 2006 to that in 2012?
Your answer should be compact. 0.29. What is the ratio of the Electricity production(% of total) of Tunisia in 2006 to that in 2012?
Your answer should be compact. 0.26. What is the ratio of the Electricity production(% of total) of European Union in 2007 to that in 2008?
Provide a succinct answer. 0.88. What is the ratio of the Electricity production(% of total) of Sub-Saharan Africa (developing only) in 2007 to that in 2008?
Give a very brief answer. 0.88. What is the ratio of the Electricity production(% of total) of Upper middle income in 2007 to that in 2008?
Your response must be concise. 0.78. What is the ratio of the Electricity production(% of total) in Tunisia in 2007 to that in 2008?
Give a very brief answer. 1.15. What is the ratio of the Electricity production(% of total) of European Union in 2007 to that in 2009?
Your response must be concise. 0.74. What is the ratio of the Electricity production(% of total) in Sub-Saharan Africa (developing only) in 2007 to that in 2009?
Your response must be concise. 0.84. What is the ratio of the Electricity production(% of total) in Upper middle income in 2007 to that in 2009?
Your answer should be very brief. 0.6. What is the ratio of the Electricity production(% of total) in Tunisia in 2007 to that in 2009?
Offer a terse response. 0.49. What is the ratio of the Electricity production(% of total) of European Union in 2007 to that in 2010?
Provide a succinct answer. 0.66. What is the ratio of the Electricity production(% of total) in Sub-Saharan Africa (developing only) in 2007 to that in 2010?
Your answer should be very brief. 0.83. What is the ratio of the Electricity production(% of total) of Upper middle income in 2007 to that in 2010?
Provide a succinct answer. 0.47. What is the ratio of the Electricity production(% of total) of Tunisia in 2007 to that in 2010?
Ensure brevity in your answer.  0.38. What is the ratio of the Electricity production(% of total) in European Union in 2007 to that in 2011?
Offer a terse response. 0.54. What is the ratio of the Electricity production(% of total) of Sub-Saharan Africa (developing only) in 2007 to that in 2011?
Keep it short and to the point. 0.86. What is the ratio of the Electricity production(% of total) of Upper middle income in 2007 to that in 2011?
Offer a very short reply. 0.39. What is the ratio of the Electricity production(% of total) in Tunisia in 2007 to that in 2011?
Provide a short and direct response. 0.47. What is the ratio of the Electricity production(% of total) in European Union in 2007 to that in 2012?
Provide a short and direct response. 0.46. What is the ratio of the Electricity production(% of total) of Sub-Saharan Africa (developing only) in 2007 to that in 2012?
Keep it short and to the point. 0.81. What is the ratio of the Electricity production(% of total) in Upper middle income in 2007 to that in 2012?
Make the answer very short. 0.33. What is the ratio of the Electricity production(% of total) in Tunisia in 2007 to that in 2012?
Keep it short and to the point. 0.28. What is the ratio of the Electricity production(% of total) in European Union in 2008 to that in 2009?
Keep it short and to the point. 0.84. What is the ratio of the Electricity production(% of total) in Sub-Saharan Africa (developing only) in 2008 to that in 2009?
Make the answer very short. 0.95. What is the ratio of the Electricity production(% of total) in Upper middle income in 2008 to that in 2009?
Your answer should be compact. 0.77. What is the ratio of the Electricity production(% of total) in Tunisia in 2008 to that in 2009?
Your answer should be compact. 0.43. What is the ratio of the Electricity production(% of total) in European Union in 2008 to that in 2010?
Your response must be concise. 0.76. What is the ratio of the Electricity production(% of total) in Sub-Saharan Africa (developing only) in 2008 to that in 2010?
Ensure brevity in your answer.  0.94. What is the ratio of the Electricity production(% of total) in Upper middle income in 2008 to that in 2010?
Provide a succinct answer. 0.6. What is the ratio of the Electricity production(% of total) in Tunisia in 2008 to that in 2010?
Provide a succinct answer. 0.33. What is the ratio of the Electricity production(% of total) in European Union in 2008 to that in 2011?
Your answer should be compact. 0.61. What is the ratio of the Electricity production(% of total) in Sub-Saharan Africa (developing only) in 2008 to that in 2011?
Offer a terse response. 0.97. What is the ratio of the Electricity production(% of total) of Upper middle income in 2008 to that in 2011?
Provide a succinct answer. 0.5. What is the ratio of the Electricity production(% of total) of Tunisia in 2008 to that in 2011?
Give a very brief answer. 0.4. What is the ratio of the Electricity production(% of total) of European Union in 2008 to that in 2012?
Offer a terse response. 0.52. What is the ratio of the Electricity production(% of total) of Sub-Saharan Africa (developing only) in 2008 to that in 2012?
Your response must be concise. 0.92. What is the ratio of the Electricity production(% of total) in Upper middle income in 2008 to that in 2012?
Give a very brief answer. 0.42. What is the ratio of the Electricity production(% of total) of Tunisia in 2008 to that in 2012?
Offer a terse response. 0.24. What is the ratio of the Electricity production(% of total) of European Union in 2009 to that in 2010?
Give a very brief answer. 0.9. What is the ratio of the Electricity production(% of total) in Upper middle income in 2009 to that in 2010?
Your answer should be very brief. 0.79. What is the ratio of the Electricity production(% of total) in Tunisia in 2009 to that in 2010?
Give a very brief answer. 0.76. What is the ratio of the Electricity production(% of total) in European Union in 2009 to that in 2011?
Offer a very short reply. 0.73. What is the ratio of the Electricity production(% of total) of Sub-Saharan Africa (developing only) in 2009 to that in 2011?
Your answer should be very brief. 1.02. What is the ratio of the Electricity production(% of total) of Upper middle income in 2009 to that in 2011?
Make the answer very short. 0.66. What is the ratio of the Electricity production(% of total) of Tunisia in 2009 to that in 2011?
Your response must be concise. 0.95. What is the ratio of the Electricity production(% of total) of European Union in 2009 to that in 2012?
Offer a terse response. 0.62. What is the ratio of the Electricity production(% of total) in Sub-Saharan Africa (developing only) in 2009 to that in 2012?
Your response must be concise. 0.97. What is the ratio of the Electricity production(% of total) in Upper middle income in 2009 to that in 2012?
Give a very brief answer. 0.55. What is the ratio of the Electricity production(% of total) of Tunisia in 2009 to that in 2012?
Make the answer very short. 0.57. What is the ratio of the Electricity production(% of total) in European Union in 2010 to that in 2011?
Your answer should be very brief. 0.81. What is the ratio of the Electricity production(% of total) in Sub-Saharan Africa (developing only) in 2010 to that in 2011?
Offer a terse response. 1.03. What is the ratio of the Electricity production(% of total) in Upper middle income in 2010 to that in 2011?
Your answer should be compact. 0.83. What is the ratio of the Electricity production(% of total) of Tunisia in 2010 to that in 2011?
Provide a succinct answer. 1.24. What is the ratio of the Electricity production(% of total) in European Union in 2010 to that in 2012?
Give a very brief answer. 0.69. What is the ratio of the Electricity production(% of total) of Sub-Saharan Africa (developing only) in 2010 to that in 2012?
Your answer should be very brief. 0.98. What is the ratio of the Electricity production(% of total) of Upper middle income in 2010 to that in 2012?
Offer a very short reply. 0.7. What is the ratio of the Electricity production(% of total) of Tunisia in 2010 to that in 2012?
Give a very brief answer. 0.74. What is the ratio of the Electricity production(% of total) of European Union in 2011 to that in 2012?
Ensure brevity in your answer.  0.85. What is the ratio of the Electricity production(% of total) of Sub-Saharan Africa (developing only) in 2011 to that in 2012?
Offer a very short reply. 0.95. What is the ratio of the Electricity production(% of total) in Upper middle income in 2011 to that in 2012?
Your answer should be very brief. 0.84. What is the ratio of the Electricity production(% of total) in Tunisia in 2011 to that in 2012?
Offer a terse response. 0.6. What is the difference between the highest and the second highest Electricity production(% of total) of European Union?
Make the answer very short. 2.04. What is the difference between the highest and the second highest Electricity production(% of total) of Sub-Saharan Africa (developing only)?
Provide a short and direct response. 0.03. What is the difference between the highest and the second highest Electricity production(% of total) in Upper middle income?
Your answer should be very brief. 0.45. What is the difference between the highest and the second highest Electricity production(% of total) of Tunisia?
Offer a very short reply. 0.28. What is the difference between the highest and the lowest Electricity production(% of total) of European Union?
Your answer should be compact. 8.15. What is the difference between the highest and the lowest Electricity production(% of total) of Sub-Saharan Africa (developing only)?
Give a very brief answer. 0.16. What is the difference between the highest and the lowest Electricity production(% of total) in Upper middle income?
Offer a terse response. 1.97. What is the difference between the highest and the lowest Electricity production(% of total) of Tunisia?
Provide a succinct answer. 0.85. 